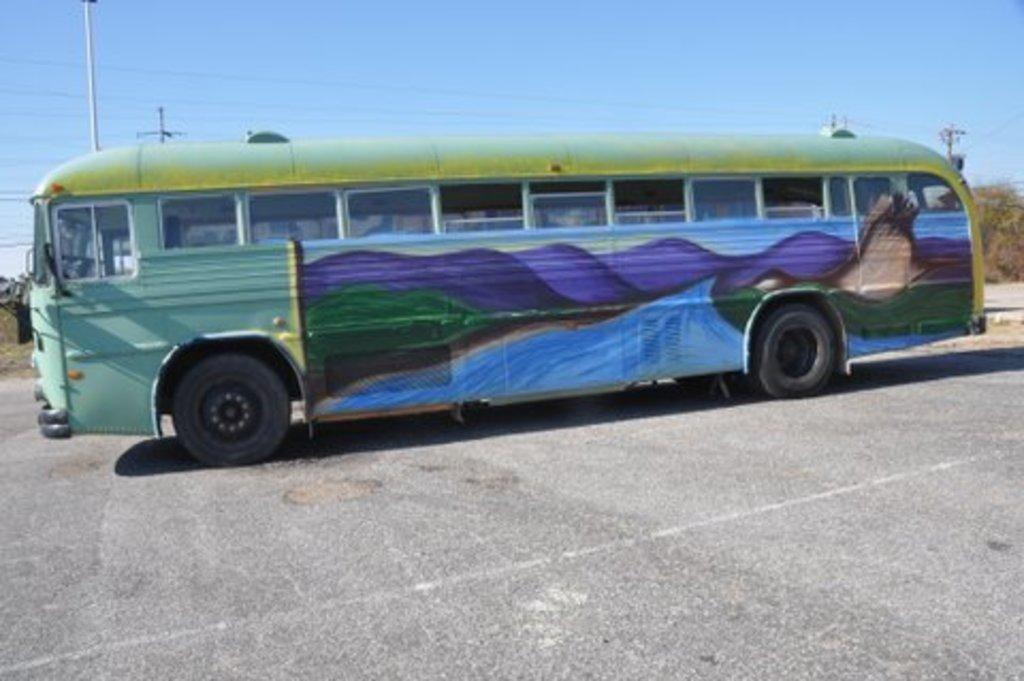What is the setting of the image? The image is an outside view. What can be seen in the middle of the image? There is a bus in the middle of the image. What is visible at the top of the image? There is a sky at the top of the image. What object is located in the top left of the image? There is a pole in the top left of the image. What type of camera is being used to take the picture of the bus? There is no information about a camera being used to take the picture, as the focus is on the image itself. 